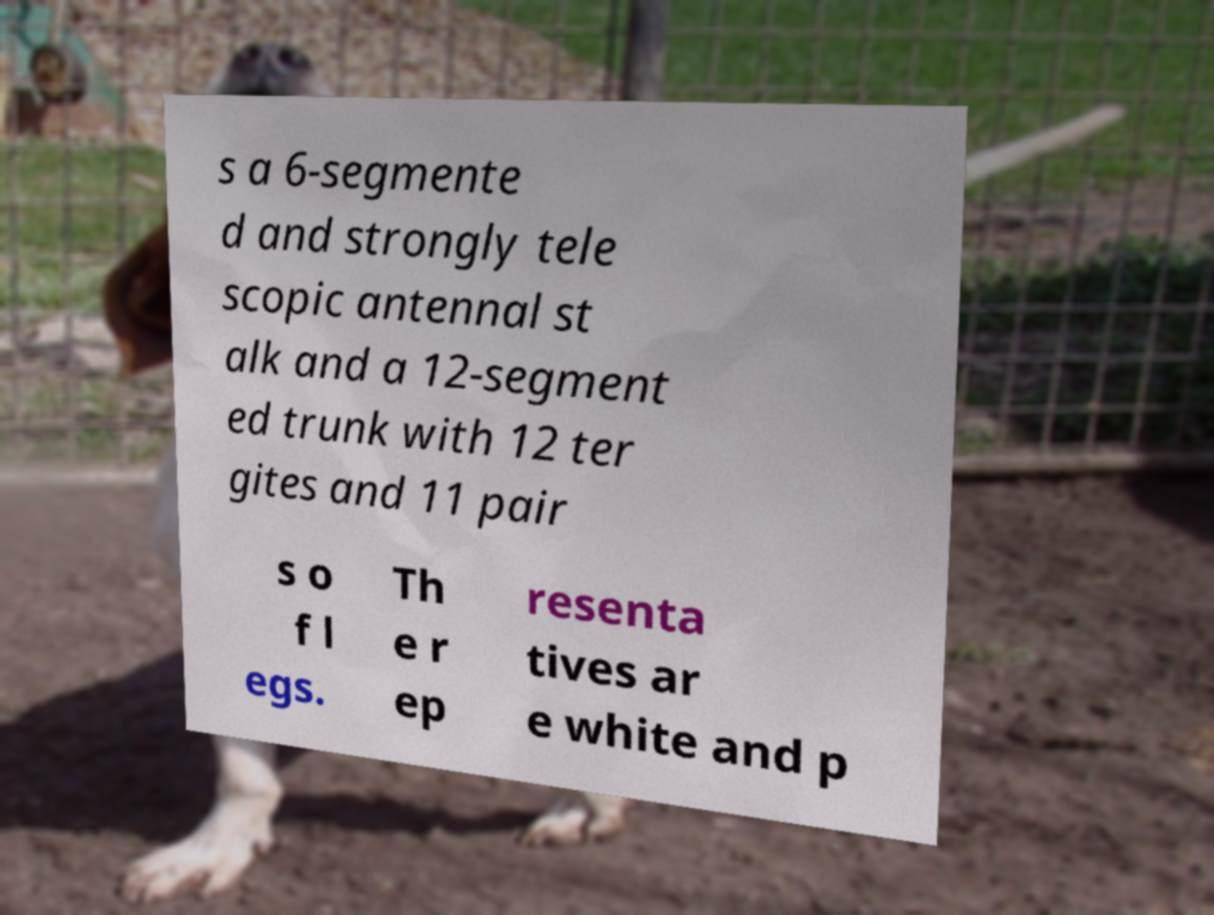For documentation purposes, I need the text within this image transcribed. Could you provide that? s a 6-segmente d and strongly tele scopic antennal st alk and a 12-segment ed trunk with 12 ter gites and 11 pair s o f l egs. Th e r ep resenta tives ar e white and p 